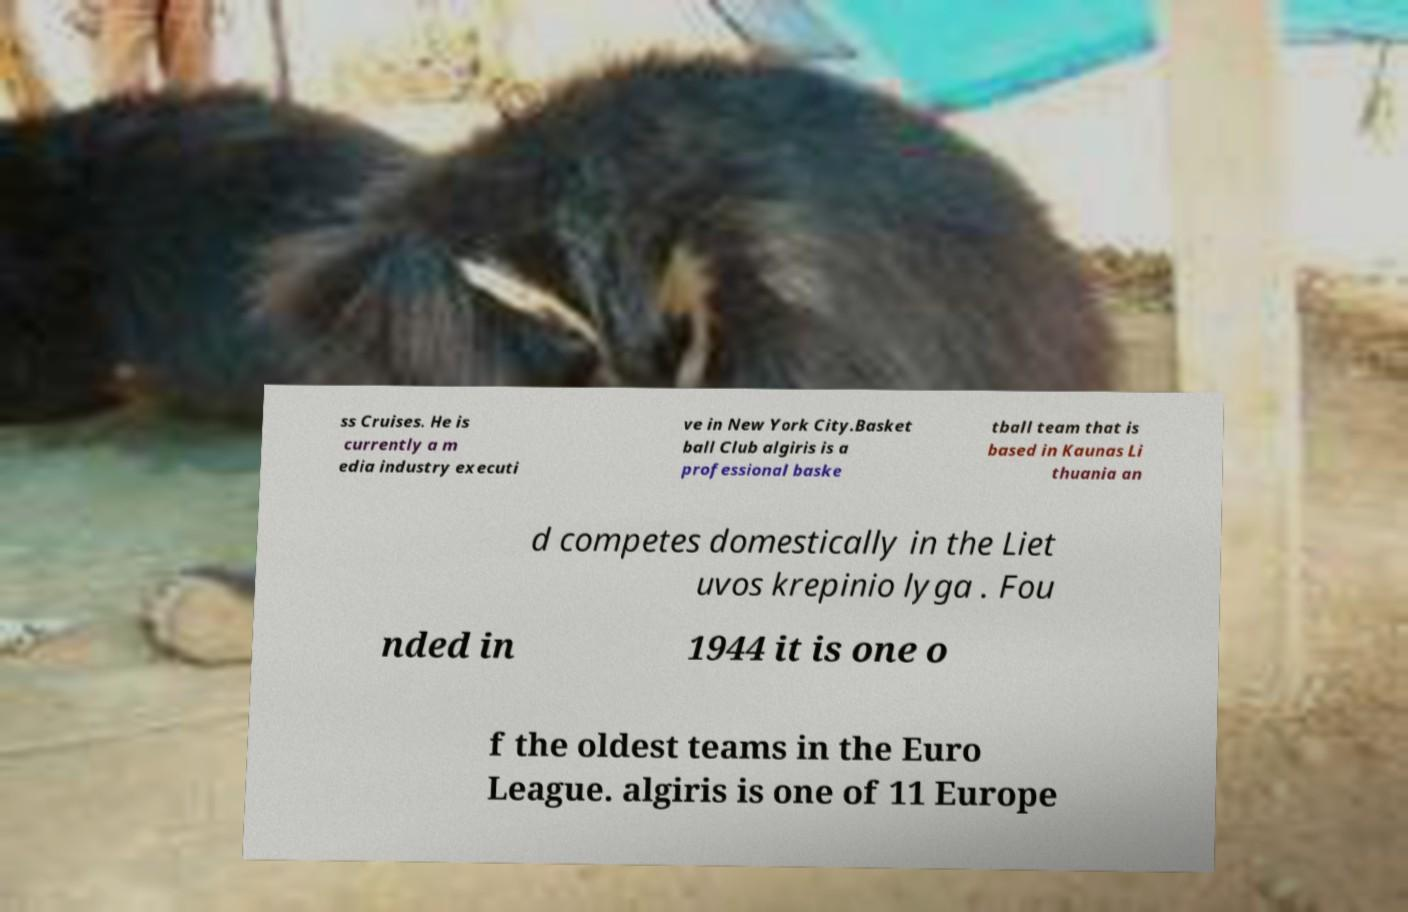There's text embedded in this image that I need extracted. Can you transcribe it verbatim? ss Cruises. He is currently a m edia industry executi ve in New York City.Basket ball Club algiris is a professional baske tball team that is based in Kaunas Li thuania an d competes domestically in the Liet uvos krepinio lyga . Fou nded in 1944 it is one o f the oldest teams in the Euro League. algiris is one of 11 Europe 